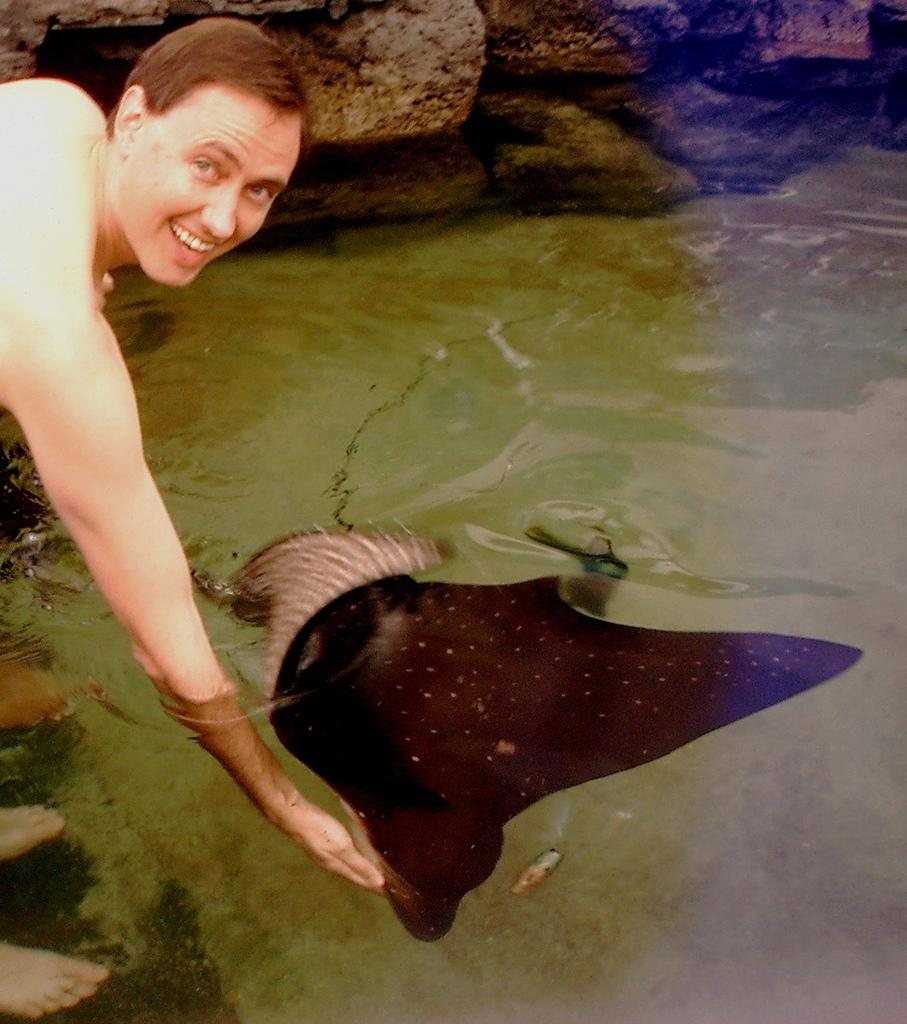What is the main subject of the image? There is a man in the image. What is the man doing in the image? The man is standing in the image. What is the man holding in the image? The man is holding a ship in the image. What is the ship doing in the image? The ship is swimming in the water in the image. What can be seen in the background of the image? There is a stone wall in the background of the image. What type of carriage can be seen passing through the gate in the image? There is no carriage or gate present in the image. What is the man's interest in the ship he is holding in the image? The image does not provide information about the man's interest in the ship he is holding. 